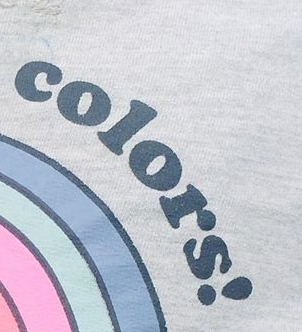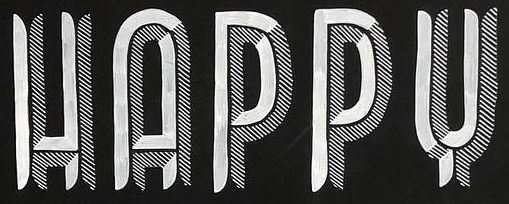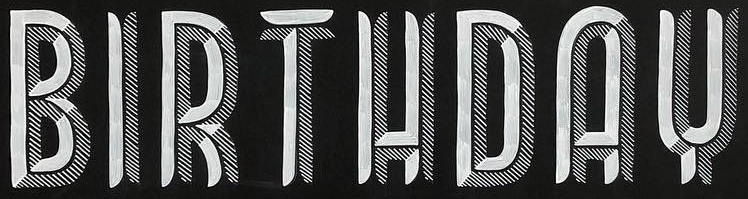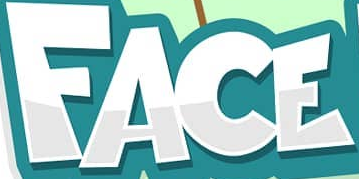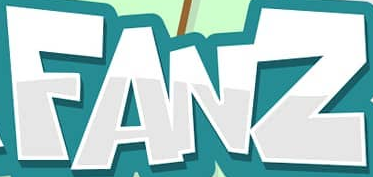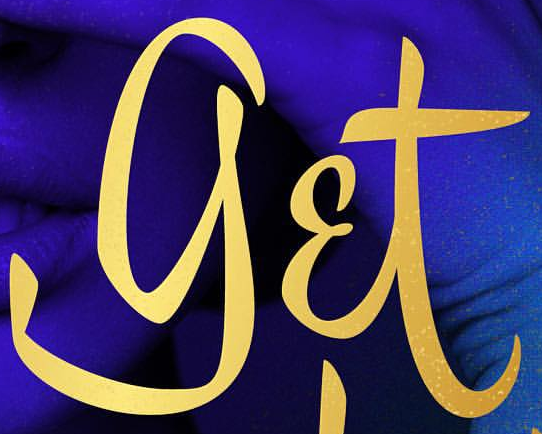Read the text from these images in sequence, separated by a semicolon. colors!; HAPPY; BIRTHDAY; FACE; FANZ; get 